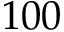<formula> <loc_0><loc_0><loc_500><loc_500>1 0 0</formula> 